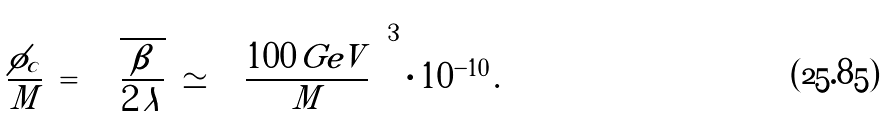<formula> <loc_0><loc_0><loc_500><loc_500>\frac { \phi _ { c } } { M } \ = \ \sqrt { \frac { \beta } { 2 \, \lambda } } \ \simeq \ \left ( \frac { 1 0 0 \, G e V } { M } \right ) ^ { 3 } \cdot 1 0 ^ { - 1 0 } \, .</formula> 